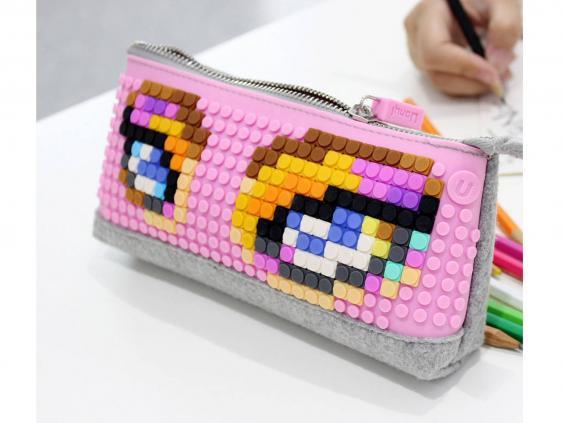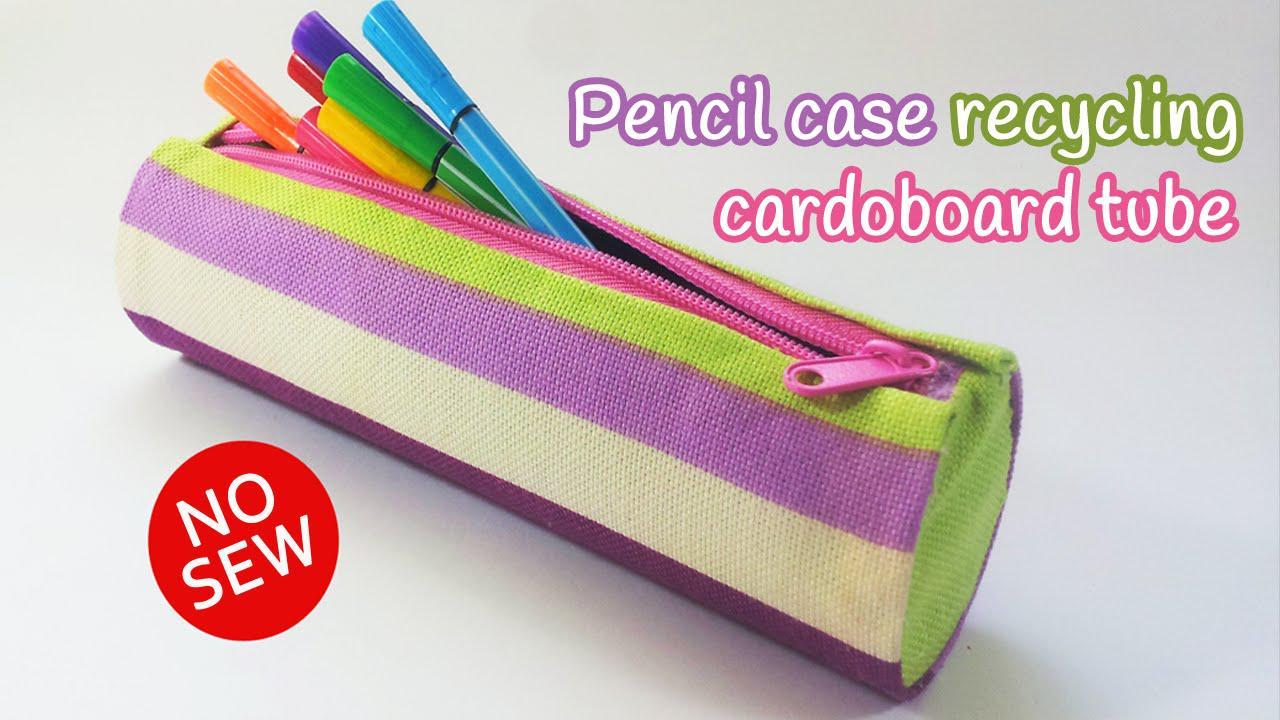The first image is the image on the left, the second image is the image on the right. Analyze the images presented: Is the assertion "The left image contain a single pencil case that is predominantly pink." valid? Answer yes or no. Yes. The first image is the image on the left, the second image is the image on the right. For the images displayed, is the sentence "Multiple writing implements are shown with pencil cases in each image." factually correct? Answer yes or no. Yes. 